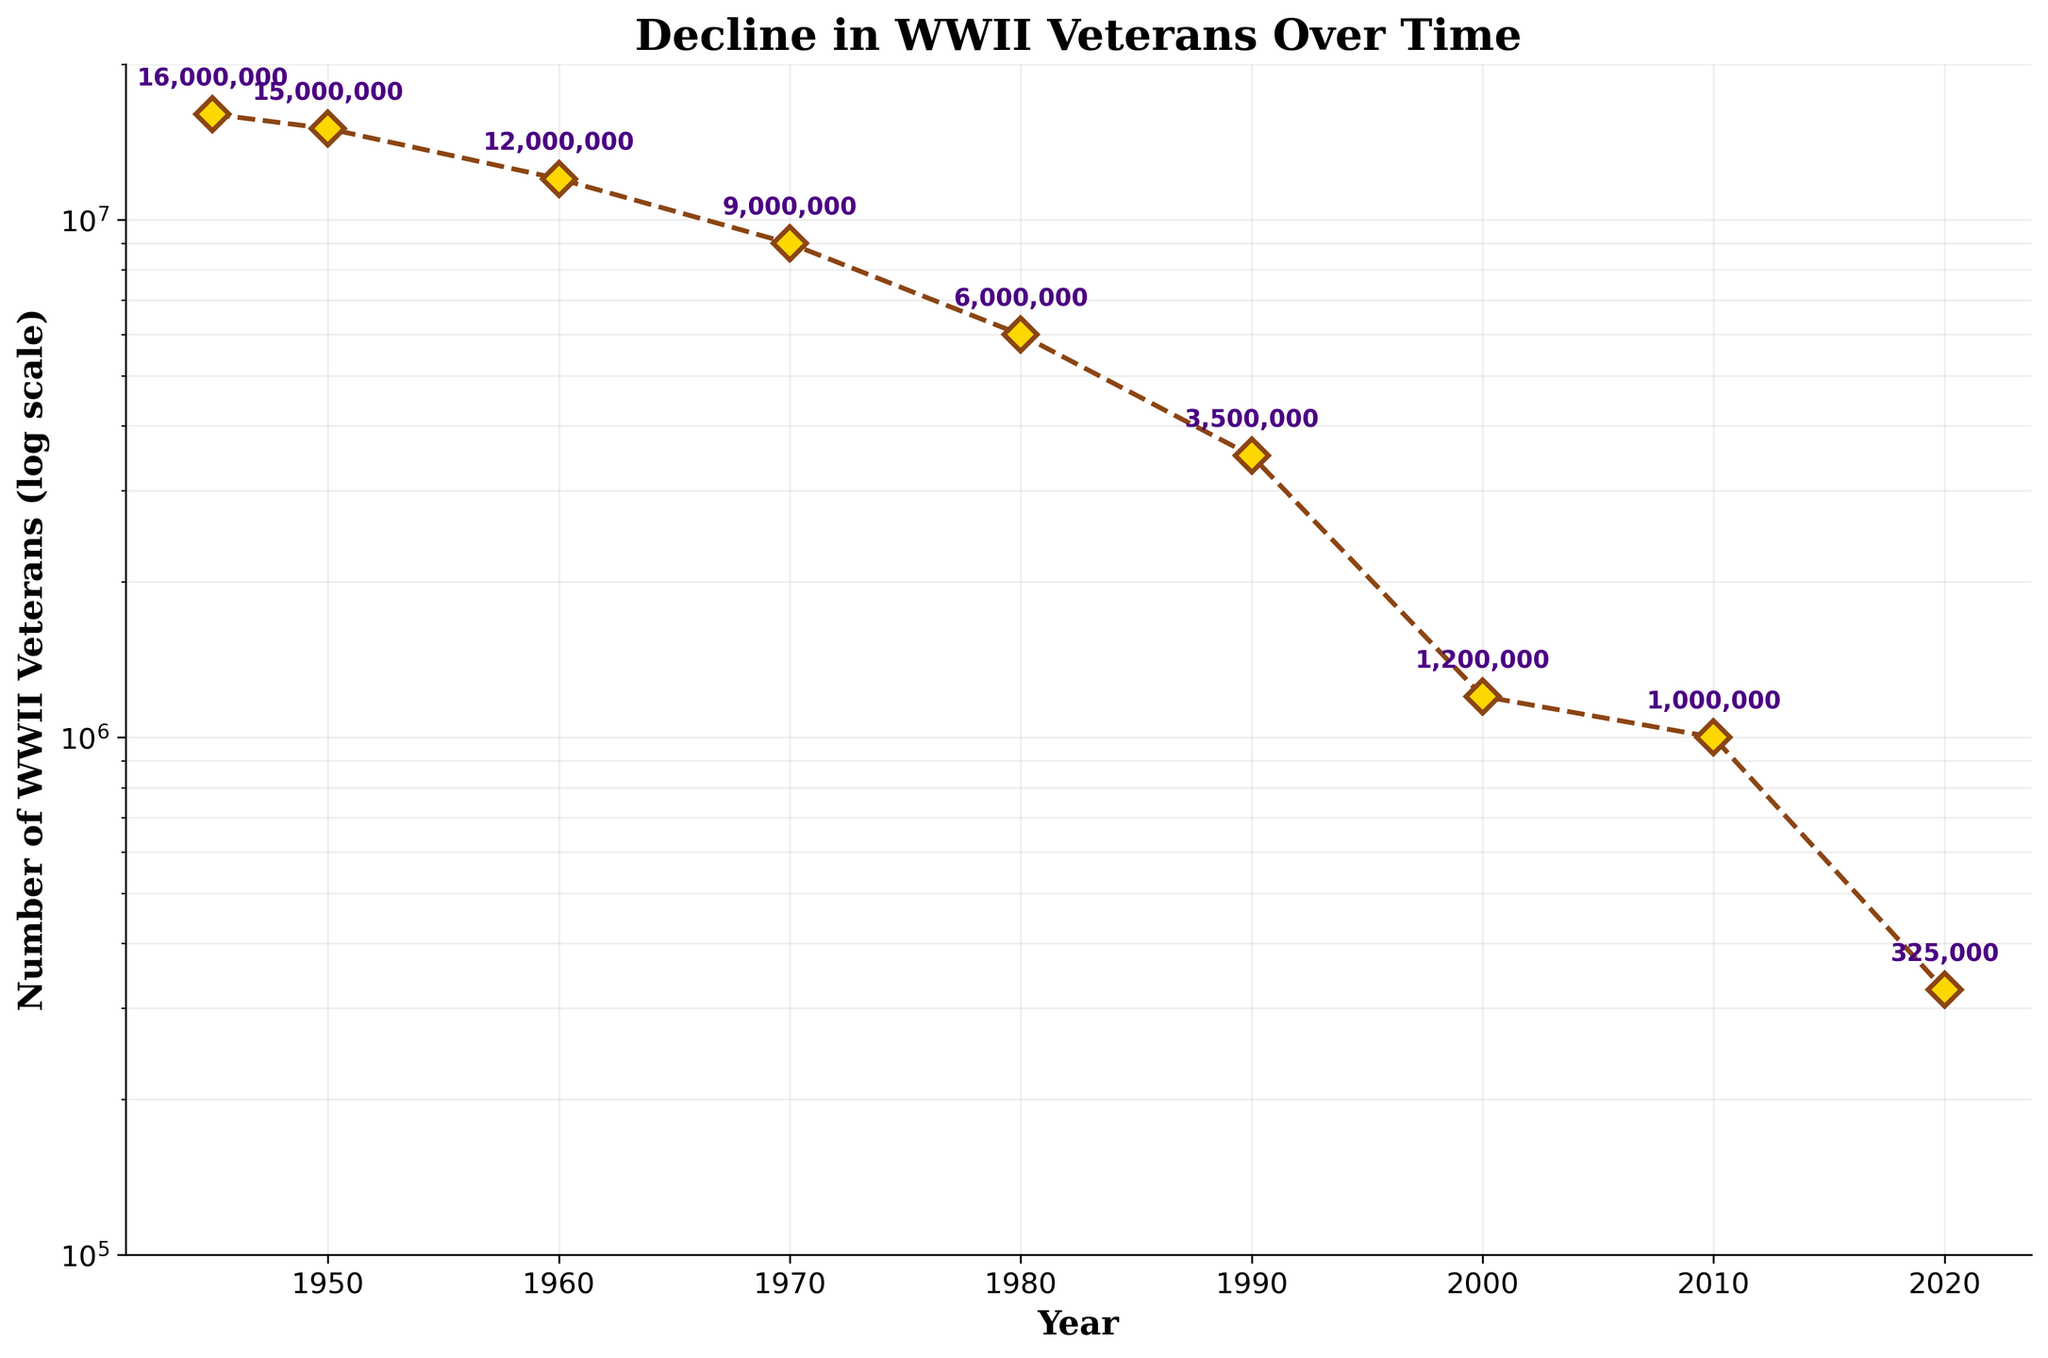What is the title of the figure? The title of a plot is typically located at the top center of the figure. In this case, it clearly reads 'Decline in WWII Veterans Over Time'.
Answer: Decline in WWII Veterans Over Time How many data points are shown on the plot? The plot presents each data point with a marker (often a specific symbol). Counting these symbols gives the total number of data points, which in this case is 9.
Answer: 9 What is the smallest number of WWII veterans recorded in the plot? On a log scale plot, each point corresponds to a specific value. The smallest value visually confirmed is 325,000 in the year 2020.
Answer: 325,000 By how much did the number of WWII veterans decrease from 1945 to 1950? Look at the y-values for the years 1945 and 1950. Subtract the veteran count in 1950 (15,000,000) from the count in 1945 (16,000,000). 16,000,000 - 15,000,000 = 1,000,000.
Answer: 1,000,000 In which year was the number of WWII veterans halved compared to the number in 1980? From 1980, the y-value is 6,000,000. Halving this amount gives 3,000,000. The closest point to 3,000,000 is 1990, with 3,500,000 veterans.
Answer: 1990 Which year saw the highest decline in the number of WWII veterans? To determine the highest annual decline, observe the differences between consecutive years. The largest drop is from 2000 to 2010, where the veteran count fell from 1,200,000 to 1,000,000.
Answer: 2000 to 2010 What is the approximate average number of WWII veterans in the years 1950, 1960, and 1970? Sum the number of veterans for these years: 15,000,000 + 12,000,000 + 9,000,000 = 36,000,000. Divide by 3 to find the average: 36,000,000 / 3 = 12,000,000.
Answer: 12,000,000 Which year recorded roughly a threefold decrease in the number of WWII veterans compared to 1970? The 1970 count is 9,000,000. Threefold decrease means 9,000,000 / 3 = 3,000,000. The closest recorded number to this is 3,500,000 in 1990.
Answer: 1990 How does the number of WWII veterans change over time according to the plot? The number of WWII veterans on the plot shows a continuous decline from 1945 to 2020.
Answer: Continuous decline 